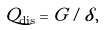<formula> <loc_0><loc_0><loc_500><loc_500>Q _ { \text {dis} } = G / \delta ,</formula> 